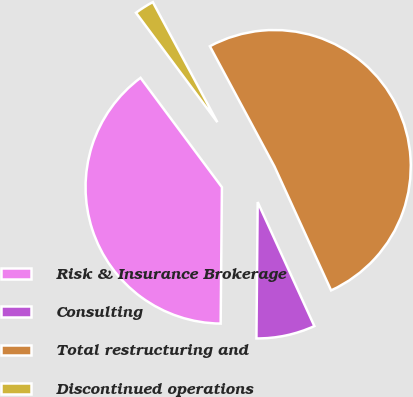Convert chart. <chart><loc_0><loc_0><loc_500><loc_500><pie_chart><fcel>Risk & Insurance Brokerage<fcel>Consulting<fcel>Total restructuring and<fcel>Discontinued operations<nl><fcel>39.67%<fcel>6.97%<fcel>51.02%<fcel>2.33%<nl></chart> 